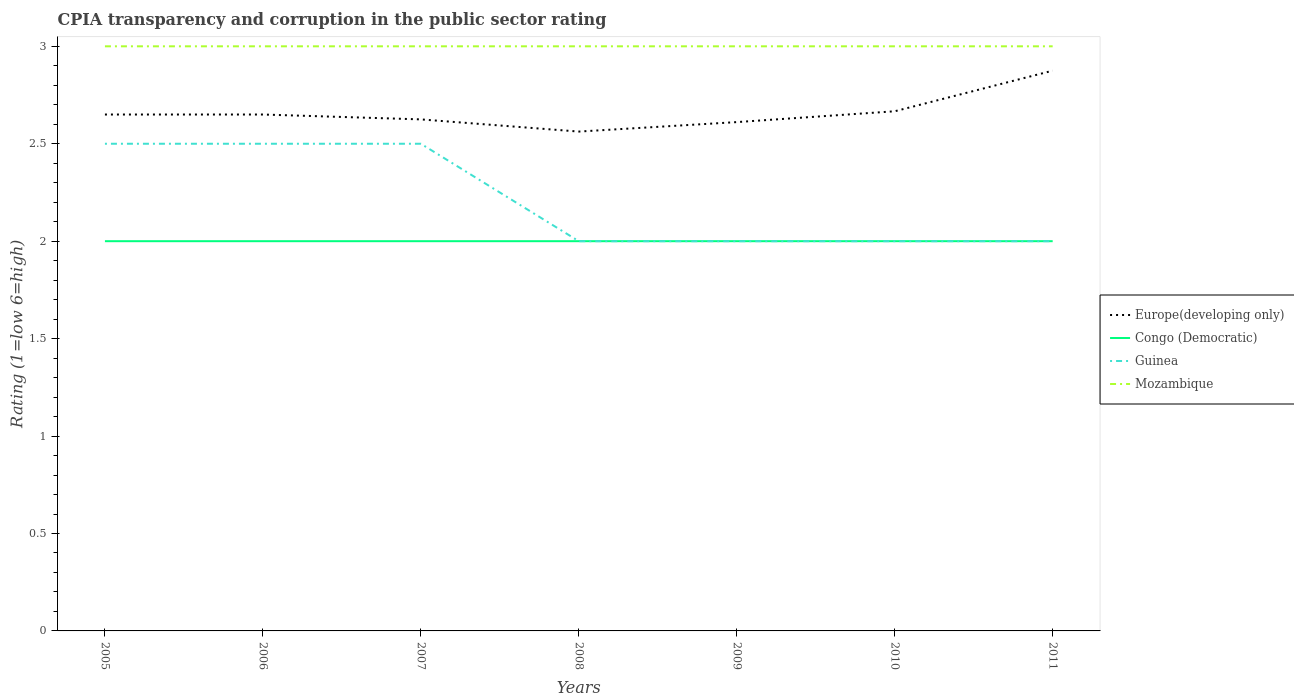Is the number of lines equal to the number of legend labels?
Give a very brief answer. Yes. Across all years, what is the maximum CPIA rating in Europe(developing only)?
Offer a terse response. 2.56. Is the CPIA rating in Europe(developing only) strictly greater than the CPIA rating in Guinea over the years?
Offer a very short reply. No. How many years are there in the graph?
Ensure brevity in your answer.  7. Are the values on the major ticks of Y-axis written in scientific E-notation?
Give a very brief answer. No. How many legend labels are there?
Your answer should be compact. 4. How are the legend labels stacked?
Make the answer very short. Vertical. What is the title of the graph?
Make the answer very short. CPIA transparency and corruption in the public sector rating. What is the label or title of the X-axis?
Provide a short and direct response. Years. What is the Rating (1=low 6=high) of Europe(developing only) in 2005?
Your answer should be compact. 2.65. What is the Rating (1=low 6=high) of Guinea in 2005?
Make the answer very short. 2.5. What is the Rating (1=low 6=high) of Europe(developing only) in 2006?
Provide a succinct answer. 2.65. What is the Rating (1=low 6=high) in Guinea in 2006?
Your answer should be compact. 2.5. What is the Rating (1=low 6=high) in Europe(developing only) in 2007?
Ensure brevity in your answer.  2.62. What is the Rating (1=low 6=high) in Congo (Democratic) in 2007?
Make the answer very short. 2. What is the Rating (1=low 6=high) in Guinea in 2007?
Keep it short and to the point. 2.5. What is the Rating (1=low 6=high) of Europe(developing only) in 2008?
Provide a succinct answer. 2.56. What is the Rating (1=low 6=high) of Congo (Democratic) in 2008?
Provide a short and direct response. 2. What is the Rating (1=low 6=high) of Guinea in 2008?
Offer a very short reply. 2. What is the Rating (1=low 6=high) of Mozambique in 2008?
Offer a very short reply. 3. What is the Rating (1=low 6=high) in Europe(developing only) in 2009?
Offer a terse response. 2.61. What is the Rating (1=low 6=high) of Congo (Democratic) in 2009?
Provide a short and direct response. 2. What is the Rating (1=low 6=high) of Mozambique in 2009?
Make the answer very short. 3. What is the Rating (1=low 6=high) of Europe(developing only) in 2010?
Your answer should be very brief. 2.67. What is the Rating (1=low 6=high) of Congo (Democratic) in 2010?
Make the answer very short. 2. What is the Rating (1=low 6=high) in Guinea in 2010?
Your response must be concise. 2. What is the Rating (1=low 6=high) in Mozambique in 2010?
Give a very brief answer. 3. What is the Rating (1=low 6=high) of Europe(developing only) in 2011?
Give a very brief answer. 2.88. What is the Rating (1=low 6=high) of Mozambique in 2011?
Offer a terse response. 3. Across all years, what is the maximum Rating (1=low 6=high) in Europe(developing only)?
Give a very brief answer. 2.88. Across all years, what is the maximum Rating (1=low 6=high) in Congo (Democratic)?
Make the answer very short. 2. Across all years, what is the maximum Rating (1=low 6=high) of Mozambique?
Keep it short and to the point. 3. Across all years, what is the minimum Rating (1=low 6=high) of Europe(developing only)?
Provide a succinct answer. 2.56. Across all years, what is the minimum Rating (1=low 6=high) of Guinea?
Ensure brevity in your answer.  2. What is the total Rating (1=low 6=high) in Europe(developing only) in the graph?
Offer a very short reply. 18.64. What is the total Rating (1=low 6=high) of Congo (Democratic) in the graph?
Offer a terse response. 14. What is the total Rating (1=low 6=high) in Mozambique in the graph?
Make the answer very short. 21. What is the difference between the Rating (1=low 6=high) of Mozambique in 2005 and that in 2006?
Provide a succinct answer. 0. What is the difference between the Rating (1=low 6=high) of Europe(developing only) in 2005 and that in 2007?
Keep it short and to the point. 0.03. What is the difference between the Rating (1=low 6=high) of Congo (Democratic) in 2005 and that in 2007?
Make the answer very short. 0. What is the difference between the Rating (1=low 6=high) of Mozambique in 2005 and that in 2007?
Provide a succinct answer. 0. What is the difference between the Rating (1=low 6=high) of Europe(developing only) in 2005 and that in 2008?
Ensure brevity in your answer.  0.09. What is the difference between the Rating (1=low 6=high) in Congo (Democratic) in 2005 and that in 2008?
Keep it short and to the point. 0. What is the difference between the Rating (1=low 6=high) in Guinea in 2005 and that in 2008?
Give a very brief answer. 0.5. What is the difference between the Rating (1=low 6=high) in Mozambique in 2005 and that in 2008?
Provide a short and direct response. 0. What is the difference between the Rating (1=low 6=high) in Europe(developing only) in 2005 and that in 2009?
Offer a terse response. 0.04. What is the difference between the Rating (1=low 6=high) of Guinea in 2005 and that in 2009?
Provide a short and direct response. 0.5. What is the difference between the Rating (1=low 6=high) in Europe(developing only) in 2005 and that in 2010?
Provide a short and direct response. -0.02. What is the difference between the Rating (1=low 6=high) in Congo (Democratic) in 2005 and that in 2010?
Offer a terse response. 0. What is the difference between the Rating (1=low 6=high) of Europe(developing only) in 2005 and that in 2011?
Provide a succinct answer. -0.23. What is the difference between the Rating (1=low 6=high) of Congo (Democratic) in 2005 and that in 2011?
Offer a terse response. 0. What is the difference between the Rating (1=low 6=high) in Guinea in 2005 and that in 2011?
Your answer should be compact. 0.5. What is the difference between the Rating (1=low 6=high) in Mozambique in 2005 and that in 2011?
Offer a very short reply. 0. What is the difference between the Rating (1=low 6=high) of Europe(developing only) in 2006 and that in 2007?
Your response must be concise. 0.03. What is the difference between the Rating (1=low 6=high) of Congo (Democratic) in 2006 and that in 2007?
Keep it short and to the point. 0. What is the difference between the Rating (1=low 6=high) of Guinea in 2006 and that in 2007?
Provide a short and direct response. 0. What is the difference between the Rating (1=low 6=high) of Mozambique in 2006 and that in 2007?
Offer a very short reply. 0. What is the difference between the Rating (1=low 6=high) of Europe(developing only) in 2006 and that in 2008?
Offer a very short reply. 0.09. What is the difference between the Rating (1=low 6=high) of Congo (Democratic) in 2006 and that in 2008?
Ensure brevity in your answer.  0. What is the difference between the Rating (1=low 6=high) of Guinea in 2006 and that in 2008?
Offer a very short reply. 0.5. What is the difference between the Rating (1=low 6=high) in Mozambique in 2006 and that in 2008?
Keep it short and to the point. 0. What is the difference between the Rating (1=low 6=high) of Europe(developing only) in 2006 and that in 2009?
Provide a succinct answer. 0.04. What is the difference between the Rating (1=low 6=high) of Congo (Democratic) in 2006 and that in 2009?
Make the answer very short. 0. What is the difference between the Rating (1=low 6=high) of Guinea in 2006 and that in 2009?
Your response must be concise. 0.5. What is the difference between the Rating (1=low 6=high) in Europe(developing only) in 2006 and that in 2010?
Offer a very short reply. -0.02. What is the difference between the Rating (1=low 6=high) in Guinea in 2006 and that in 2010?
Give a very brief answer. 0.5. What is the difference between the Rating (1=low 6=high) of Mozambique in 2006 and that in 2010?
Offer a terse response. 0. What is the difference between the Rating (1=low 6=high) of Europe(developing only) in 2006 and that in 2011?
Your answer should be very brief. -0.23. What is the difference between the Rating (1=low 6=high) of Guinea in 2006 and that in 2011?
Your response must be concise. 0.5. What is the difference between the Rating (1=low 6=high) in Europe(developing only) in 2007 and that in 2008?
Provide a succinct answer. 0.06. What is the difference between the Rating (1=low 6=high) of Europe(developing only) in 2007 and that in 2009?
Offer a terse response. 0.01. What is the difference between the Rating (1=low 6=high) of Guinea in 2007 and that in 2009?
Your answer should be very brief. 0.5. What is the difference between the Rating (1=low 6=high) in Europe(developing only) in 2007 and that in 2010?
Your answer should be very brief. -0.04. What is the difference between the Rating (1=low 6=high) of Congo (Democratic) in 2007 and that in 2010?
Give a very brief answer. 0. What is the difference between the Rating (1=low 6=high) in Congo (Democratic) in 2007 and that in 2011?
Keep it short and to the point. 0. What is the difference between the Rating (1=low 6=high) of Europe(developing only) in 2008 and that in 2009?
Provide a succinct answer. -0.05. What is the difference between the Rating (1=low 6=high) in Congo (Democratic) in 2008 and that in 2009?
Give a very brief answer. 0. What is the difference between the Rating (1=low 6=high) of Guinea in 2008 and that in 2009?
Keep it short and to the point. 0. What is the difference between the Rating (1=low 6=high) of Mozambique in 2008 and that in 2009?
Your response must be concise. 0. What is the difference between the Rating (1=low 6=high) in Europe(developing only) in 2008 and that in 2010?
Make the answer very short. -0.1. What is the difference between the Rating (1=low 6=high) of Mozambique in 2008 and that in 2010?
Provide a succinct answer. 0. What is the difference between the Rating (1=low 6=high) in Europe(developing only) in 2008 and that in 2011?
Your answer should be compact. -0.31. What is the difference between the Rating (1=low 6=high) in Congo (Democratic) in 2008 and that in 2011?
Keep it short and to the point. 0. What is the difference between the Rating (1=low 6=high) in Europe(developing only) in 2009 and that in 2010?
Ensure brevity in your answer.  -0.06. What is the difference between the Rating (1=low 6=high) of Congo (Democratic) in 2009 and that in 2010?
Your response must be concise. 0. What is the difference between the Rating (1=low 6=high) in Europe(developing only) in 2009 and that in 2011?
Your answer should be very brief. -0.26. What is the difference between the Rating (1=low 6=high) in Guinea in 2009 and that in 2011?
Keep it short and to the point. 0. What is the difference between the Rating (1=low 6=high) in Europe(developing only) in 2010 and that in 2011?
Make the answer very short. -0.21. What is the difference between the Rating (1=low 6=high) in Congo (Democratic) in 2010 and that in 2011?
Make the answer very short. 0. What is the difference between the Rating (1=low 6=high) of Guinea in 2010 and that in 2011?
Your response must be concise. 0. What is the difference between the Rating (1=low 6=high) in Mozambique in 2010 and that in 2011?
Offer a very short reply. 0. What is the difference between the Rating (1=low 6=high) of Europe(developing only) in 2005 and the Rating (1=low 6=high) of Congo (Democratic) in 2006?
Provide a short and direct response. 0.65. What is the difference between the Rating (1=low 6=high) in Europe(developing only) in 2005 and the Rating (1=low 6=high) in Guinea in 2006?
Offer a terse response. 0.15. What is the difference between the Rating (1=low 6=high) in Europe(developing only) in 2005 and the Rating (1=low 6=high) in Mozambique in 2006?
Offer a very short reply. -0.35. What is the difference between the Rating (1=low 6=high) in Congo (Democratic) in 2005 and the Rating (1=low 6=high) in Guinea in 2006?
Ensure brevity in your answer.  -0.5. What is the difference between the Rating (1=low 6=high) of Congo (Democratic) in 2005 and the Rating (1=low 6=high) of Mozambique in 2006?
Make the answer very short. -1. What is the difference between the Rating (1=low 6=high) in Guinea in 2005 and the Rating (1=low 6=high) in Mozambique in 2006?
Your response must be concise. -0.5. What is the difference between the Rating (1=low 6=high) in Europe(developing only) in 2005 and the Rating (1=low 6=high) in Congo (Democratic) in 2007?
Give a very brief answer. 0.65. What is the difference between the Rating (1=low 6=high) of Europe(developing only) in 2005 and the Rating (1=low 6=high) of Mozambique in 2007?
Make the answer very short. -0.35. What is the difference between the Rating (1=low 6=high) in Congo (Democratic) in 2005 and the Rating (1=low 6=high) in Mozambique in 2007?
Offer a terse response. -1. What is the difference between the Rating (1=low 6=high) of Europe(developing only) in 2005 and the Rating (1=low 6=high) of Congo (Democratic) in 2008?
Offer a terse response. 0.65. What is the difference between the Rating (1=low 6=high) in Europe(developing only) in 2005 and the Rating (1=low 6=high) in Guinea in 2008?
Give a very brief answer. 0.65. What is the difference between the Rating (1=low 6=high) of Europe(developing only) in 2005 and the Rating (1=low 6=high) of Mozambique in 2008?
Make the answer very short. -0.35. What is the difference between the Rating (1=low 6=high) of Congo (Democratic) in 2005 and the Rating (1=low 6=high) of Guinea in 2008?
Offer a very short reply. 0. What is the difference between the Rating (1=low 6=high) of Guinea in 2005 and the Rating (1=low 6=high) of Mozambique in 2008?
Your response must be concise. -0.5. What is the difference between the Rating (1=low 6=high) of Europe(developing only) in 2005 and the Rating (1=low 6=high) of Congo (Democratic) in 2009?
Provide a short and direct response. 0.65. What is the difference between the Rating (1=low 6=high) in Europe(developing only) in 2005 and the Rating (1=low 6=high) in Guinea in 2009?
Give a very brief answer. 0.65. What is the difference between the Rating (1=low 6=high) of Europe(developing only) in 2005 and the Rating (1=low 6=high) of Mozambique in 2009?
Your answer should be compact. -0.35. What is the difference between the Rating (1=low 6=high) of Congo (Democratic) in 2005 and the Rating (1=low 6=high) of Guinea in 2009?
Your response must be concise. 0. What is the difference between the Rating (1=low 6=high) of Guinea in 2005 and the Rating (1=low 6=high) of Mozambique in 2009?
Keep it short and to the point. -0.5. What is the difference between the Rating (1=low 6=high) in Europe(developing only) in 2005 and the Rating (1=low 6=high) in Congo (Democratic) in 2010?
Keep it short and to the point. 0.65. What is the difference between the Rating (1=low 6=high) in Europe(developing only) in 2005 and the Rating (1=low 6=high) in Guinea in 2010?
Provide a succinct answer. 0.65. What is the difference between the Rating (1=low 6=high) of Europe(developing only) in 2005 and the Rating (1=low 6=high) of Mozambique in 2010?
Your response must be concise. -0.35. What is the difference between the Rating (1=low 6=high) in Congo (Democratic) in 2005 and the Rating (1=low 6=high) in Mozambique in 2010?
Offer a very short reply. -1. What is the difference between the Rating (1=low 6=high) in Europe(developing only) in 2005 and the Rating (1=low 6=high) in Congo (Democratic) in 2011?
Offer a terse response. 0.65. What is the difference between the Rating (1=low 6=high) of Europe(developing only) in 2005 and the Rating (1=low 6=high) of Guinea in 2011?
Offer a terse response. 0.65. What is the difference between the Rating (1=low 6=high) in Europe(developing only) in 2005 and the Rating (1=low 6=high) in Mozambique in 2011?
Ensure brevity in your answer.  -0.35. What is the difference between the Rating (1=low 6=high) in Europe(developing only) in 2006 and the Rating (1=low 6=high) in Congo (Democratic) in 2007?
Keep it short and to the point. 0.65. What is the difference between the Rating (1=low 6=high) of Europe(developing only) in 2006 and the Rating (1=low 6=high) of Guinea in 2007?
Ensure brevity in your answer.  0.15. What is the difference between the Rating (1=low 6=high) in Europe(developing only) in 2006 and the Rating (1=low 6=high) in Mozambique in 2007?
Offer a very short reply. -0.35. What is the difference between the Rating (1=low 6=high) in Congo (Democratic) in 2006 and the Rating (1=low 6=high) in Guinea in 2007?
Keep it short and to the point. -0.5. What is the difference between the Rating (1=low 6=high) in Congo (Democratic) in 2006 and the Rating (1=low 6=high) in Mozambique in 2007?
Give a very brief answer. -1. What is the difference between the Rating (1=low 6=high) in Europe(developing only) in 2006 and the Rating (1=low 6=high) in Congo (Democratic) in 2008?
Ensure brevity in your answer.  0.65. What is the difference between the Rating (1=low 6=high) in Europe(developing only) in 2006 and the Rating (1=low 6=high) in Guinea in 2008?
Provide a short and direct response. 0.65. What is the difference between the Rating (1=low 6=high) in Europe(developing only) in 2006 and the Rating (1=low 6=high) in Mozambique in 2008?
Your answer should be compact. -0.35. What is the difference between the Rating (1=low 6=high) in Congo (Democratic) in 2006 and the Rating (1=low 6=high) in Mozambique in 2008?
Ensure brevity in your answer.  -1. What is the difference between the Rating (1=low 6=high) in Guinea in 2006 and the Rating (1=low 6=high) in Mozambique in 2008?
Offer a very short reply. -0.5. What is the difference between the Rating (1=low 6=high) of Europe(developing only) in 2006 and the Rating (1=low 6=high) of Congo (Democratic) in 2009?
Make the answer very short. 0.65. What is the difference between the Rating (1=low 6=high) in Europe(developing only) in 2006 and the Rating (1=low 6=high) in Guinea in 2009?
Provide a succinct answer. 0.65. What is the difference between the Rating (1=low 6=high) of Europe(developing only) in 2006 and the Rating (1=low 6=high) of Mozambique in 2009?
Offer a terse response. -0.35. What is the difference between the Rating (1=low 6=high) of Europe(developing only) in 2006 and the Rating (1=low 6=high) of Congo (Democratic) in 2010?
Provide a short and direct response. 0.65. What is the difference between the Rating (1=low 6=high) in Europe(developing only) in 2006 and the Rating (1=low 6=high) in Guinea in 2010?
Provide a short and direct response. 0.65. What is the difference between the Rating (1=low 6=high) of Europe(developing only) in 2006 and the Rating (1=low 6=high) of Mozambique in 2010?
Your response must be concise. -0.35. What is the difference between the Rating (1=low 6=high) in Congo (Democratic) in 2006 and the Rating (1=low 6=high) in Guinea in 2010?
Offer a very short reply. 0. What is the difference between the Rating (1=low 6=high) in Guinea in 2006 and the Rating (1=low 6=high) in Mozambique in 2010?
Your response must be concise. -0.5. What is the difference between the Rating (1=low 6=high) of Europe(developing only) in 2006 and the Rating (1=low 6=high) of Congo (Democratic) in 2011?
Offer a terse response. 0.65. What is the difference between the Rating (1=low 6=high) of Europe(developing only) in 2006 and the Rating (1=low 6=high) of Guinea in 2011?
Your answer should be compact. 0.65. What is the difference between the Rating (1=low 6=high) in Europe(developing only) in 2006 and the Rating (1=low 6=high) in Mozambique in 2011?
Offer a very short reply. -0.35. What is the difference between the Rating (1=low 6=high) of Congo (Democratic) in 2006 and the Rating (1=low 6=high) of Guinea in 2011?
Offer a very short reply. 0. What is the difference between the Rating (1=low 6=high) in Guinea in 2006 and the Rating (1=low 6=high) in Mozambique in 2011?
Provide a short and direct response. -0.5. What is the difference between the Rating (1=low 6=high) of Europe(developing only) in 2007 and the Rating (1=low 6=high) of Guinea in 2008?
Keep it short and to the point. 0.62. What is the difference between the Rating (1=low 6=high) of Europe(developing only) in 2007 and the Rating (1=low 6=high) of Mozambique in 2008?
Make the answer very short. -0.38. What is the difference between the Rating (1=low 6=high) of Congo (Democratic) in 2007 and the Rating (1=low 6=high) of Mozambique in 2008?
Ensure brevity in your answer.  -1. What is the difference between the Rating (1=low 6=high) in Europe(developing only) in 2007 and the Rating (1=low 6=high) in Congo (Democratic) in 2009?
Your answer should be compact. 0.62. What is the difference between the Rating (1=low 6=high) of Europe(developing only) in 2007 and the Rating (1=low 6=high) of Guinea in 2009?
Provide a short and direct response. 0.62. What is the difference between the Rating (1=low 6=high) of Europe(developing only) in 2007 and the Rating (1=low 6=high) of Mozambique in 2009?
Provide a short and direct response. -0.38. What is the difference between the Rating (1=low 6=high) of Congo (Democratic) in 2007 and the Rating (1=low 6=high) of Mozambique in 2009?
Keep it short and to the point. -1. What is the difference between the Rating (1=low 6=high) of Europe(developing only) in 2007 and the Rating (1=low 6=high) of Guinea in 2010?
Offer a very short reply. 0.62. What is the difference between the Rating (1=low 6=high) of Europe(developing only) in 2007 and the Rating (1=low 6=high) of Mozambique in 2010?
Provide a short and direct response. -0.38. What is the difference between the Rating (1=low 6=high) of Congo (Democratic) in 2007 and the Rating (1=low 6=high) of Mozambique in 2010?
Ensure brevity in your answer.  -1. What is the difference between the Rating (1=low 6=high) of Guinea in 2007 and the Rating (1=low 6=high) of Mozambique in 2010?
Keep it short and to the point. -0.5. What is the difference between the Rating (1=low 6=high) in Europe(developing only) in 2007 and the Rating (1=low 6=high) in Guinea in 2011?
Ensure brevity in your answer.  0.62. What is the difference between the Rating (1=low 6=high) of Europe(developing only) in 2007 and the Rating (1=low 6=high) of Mozambique in 2011?
Your answer should be very brief. -0.38. What is the difference between the Rating (1=low 6=high) in Congo (Democratic) in 2007 and the Rating (1=low 6=high) in Guinea in 2011?
Offer a terse response. 0. What is the difference between the Rating (1=low 6=high) in Europe(developing only) in 2008 and the Rating (1=low 6=high) in Congo (Democratic) in 2009?
Keep it short and to the point. 0.56. What is the difference between the Rating (1=low 6=high) in Europe(developing only) in 2008 and the Rating (1=low 6=high) in Guinea in 2009?
Offer a terse response. 0.56. What is the difference between the Rating (1=low 6=high) of Europe(developing only) in 2008 and the Rating (1=low 6=high) of Mozambique in 2009?
Your response must be concise. -0.44. What is the difference between the Rating (1=low 6=high) of Congo (Democratic) in 2008 and the Rating (1=low 6=high) of Guinea in 2009?
Offer a very short reply. 0. What is the difference between the Rating (1=low 6=high) in Congo (Democratic) in 2008 and the Rating (1=low 6=high) in Mozambique in 2009?
Provide a short and direct response. -1. What is the difference between the Rating (1=low 6=high) in Europe(developing only) in 2008 and the Rating (1=low 6=high) in Congo (Democratic) in 2010?
Offer a very short reply. 0.56. What is the difference between the Rating (1=low 6=high) in Europe(developing only) in 2008 and the Rating (1=low 6=high) in Guinea in 2010?
Your response must be concise. 0.56. What is the difference between the Rating (1=low 6=high) in Europe(developing only) in 2008 and the Rating (1=low 6=high) in Mozambique in 2010?
Keep it short and to the point. -0.44. What is the difference between the Rating (1=low 6=high) of Congo (Democratic) in 2008 and the Rating (1=low 6=high) of Guinea in 2010?
Give a very brief answer. 0. What is the difference between the Rating (1=low 6=high) of Guinea in 2008 and the Rating (1=low 6=high) of Mozambique in 2010?
Ensure brevity in your answer.  -1. What is the difference between the Rating (1=low 6=high) in Europe(developing only) in 2008 and the Rating (1=low 6=high) in Congo (Democratic) in 2011?
Your answer should be very brief. 0.56. What is the difference between the Rating (1=low 6=high) of Europe(developing only) in 2008 and the Rating (1=low 6=high) of Guinea in 2011?
Offer a terse response. 0.56. What is the difference between the Rating (1=low 6=high) in Europe(developing only) in 2008 and the Rating (1=low 6=high) in Mozambique in 2011?
Keep it short and to the point. -0.44. What is the difference between the Rating (1=low 6=high) of Congo (Democratic) in 2008 and the Rating (1=low 6=high) of Guinea in 2011?
Make the answer very short. 0. What is the difference between the Rating (1=low 6=high) in Congo (Democratic) in 2008 and the Rating (1=low 6=high) in Mozambique in 2011?
Ensure brevity in your answer.  -1. What is the difference between the Rating (1=low 6=high) in Europe(developing only) in 2009 and the Rating (1=low 6=high) in Congo (Democratic) in 2010?
Your response must be concise. 0.61. What is the difference between the Rating (1=low 6=high) of Europe(developing only) in 2009 and the Rating (1=low 6=high) of Guinea in 2010?
Provide a succinct answer. 0.61. What is the difference between the Rating (1=low 6=high) in Europe(developing only) in 2009 and the Rating (1=low 6=high) in Mozambique in 2010?
Offer a very short reply. -0.39. What is the difference between the Rating (1=low 6=high) in Europe(developing only) in 2009 and the Rating (1=low 6=high) in Congo (Democratic) in 2011?
Your response must be concise. 0.61. What is the difference between the Rating (1=low 6=high) in Europe(developing only) in 2009 and the Rating (1=low 6=high) in Guinea in 2011?
Your answer should be very brief. 0.61. What is the difference between the Rating (1=low 6=high) of Europe(developing only) in 2009 and the Rating (1=low 6=high) of Mozambique in 2011?
Ensure brevity in your answer.  -0.39. What is the difference between the Rating (1=low 6=high) in Congo (Democratic) in 2009 and the Rating (1=low 6=high) in Guinea in 2011?
Make the answer very short. 0. What is the difference between the Rating (1=low 6=high) of Congo (Democratic) in 2009 and the Rating (1=low 6=high) of Mozambique in 2011?
Offer a very short reply. -1. What is the difference between the Rating (1=low 6=high) in Guinea in 2009 and the Rating (1=low 6=high) in Mozambique in 2011?
Give a very brief answer. -1. What is the difference between the Rating (1=low 6=high) in Europe(developing only) in 2010 and the Rating (1=low 6=high) in Guinea in 2011?
Provide a succinct answer. 0.67. What is the difference between the Rating (1=low 6=high) of Guinea in 2010 and the Rating (1=low 6=high) of Mozambique in 2011?
Keep it short and to the point. -1. What is the average Rating (1=low 6=high) of Europe(developing only) per year?
Your response must be concise. 2.66. What is the average Rating (1=low 6=high) in Guinea per year?
Ensure brevity in your answer.  2.21. In the year 2005, what is the difference between the Rating (1=low 6=high) of Europe(developing only) and Rating (1=low 6=high) of Congo (Democratic)?
Offer a very short reply. 0.65. In the year 2005, what is the difference between the Rating (1=low 6=high) of Europe(developing only) and Rating (1=low 6=high) of Guinea?
Provide a short and direct response. 0.15. In the year 2005, what is the difference between the Rating (1=low 6=high) of Europe(developing only) and Rating (1=low 6=high) of Mozambique?
Offer a terse response. -0.35. In the year 2005, what is the difference between the Rating (1=low 6=high) in Congo (Democratic) and Rating (1=low 6=high) in Guinea?
Give a very brief answer. -0.5. In the year 2005, what is the difference between the Rating (1=low 6=high) of Congo (Democratic) and Rating (1=low 6=high) of Mozambique?
Provide a succinct answer. -1. In the year 2006, what is the difference between the Rating (1=low 6=high) in Europe(developing only) and Rating (1=low 6=high) in Congo (Democratic)?
Keep it short and to the point. 0.65. In the year 2006, what is the difference between the Rating (1=low 6=high) of Europe(developing only) and Rating (1=low 6=high) of Guinea?
Ensure brevity in your answer.  0.15. In the year 2006, what is the difference between the Rating (1=low 6=high) in Europe(developing only) and Rating (1=low 6=high) in Mozambique?
Keep it short and to the point. -0.35. In the year 2006, what is the difference between the Rating (1=low 6=high) of Congo (Democratic) and Rating (1=low 6=high) of Guinea?
Provide a short and direct response. -0.5. In the year 2007, what is the difference between the Rating (1=low 6=high) of Europe(developing only) and Rating (1=low 6=high) of Congo (Democratic)?
Your response must be concise. 0.62. In the year 2007, what is the difference between the Rating (1=low 6=high) of Europe(developing only) and Rating (1=low 6=high) of Guinea?
Give a very brief answer. 0.12. In the year 2007, what is the difference between the Rating (1=low 6=high) of Europe(developing only) and Rating (1=low 6=high) of Mozambique?
Keep it short and to the point. -0.38. In the year 2007, what is the difference between the Rating (1=low 6=high) of Congo (Democratic) and Rating (1=low 6=high) of Mozambique?
Your answer should be very brief. -1. In the year 2007, what is the difference between the Rating (1=low 6=high) of Guinea and Rating (1=low 6=high) of Mozambique?
Provide a short and direct response. -0.5. In the year 2008, what is the difference between the Rating (1=low 6=high) of Europe(developing only) and Rating (1=low 6=high) of Congo (Democratic)?
Keep it short and to the point. 0.56. In the year 2008, what is the difference between the Rating (1=low 6=high) of Europe(developing only) and Rating (1=low 6=high) of Guinea?
Your answer should be compact. 0.56. In the year 2008, what is the difference between the Rating (1=low 6=high) in Europe(developing only) and Rating (1=low 6=high) in Mozambique?
Provide a short and direct response. -0.44. In the year 2008, what is the difference between the Rating (1=low 6=high) of Congo (Democratic) and Rating (1=low 6=high) of Guinea?
Your answer should be very brief. 0. In the year 2008, what is the difference between the Rating (1=low 6=high) in Guinea and Rating (1=low 6=high) in Mozambique?
Ensure brevity in your answer.  -1. In the year 2009, what is the difference between the Rating (1=low 6=high) of Europe(developing only) and Rating (1=low 6=high) of Congo (Democratic)?
Make the answer very short. 0.61. In the year 2009, what is the difference between the Rating (1=low 6=high) of Europe(developing only) and Rating (1=low 6=high) of Guinea?
Make the answer very short. 0.61. In the year 2009, what is the difference between the Rating (1=low 6=high) of Europe(developing only) and Rating (1=low 6=high) of Mozambique?
Ensure brevity in your answer.  -0.39. In the year 2009, what is the difference between the Rating (1=low 6=high) of Congo (Democratic) and Rating (1=low 6=high) of Mozambique?
Your response must be concise. -1. In the year 2010, what is the difference between the Rating (1=low 6=high) of Europe(developing only) and Rating (1=low 6=high) of Guinea?
Offer a very short reply. 0.67. In the year 2010, what is the difference between the Rating (1=low 6=high) of Europe(developing only) and Rating (1=low 6=high) of Mozambique?
Make the answer very short. -0.33. In the year 2010, what is the difference between the Rating (1=low 6=high) in Congo (Democratic) and Rating (1=low 6=high) in Mozambique?
Your answer should be compact. -1. In the year 2011, what is the difference between the Rating (1=low 6=high) in Europe(developing only) and Rating (1=low 6=high) in Congo (Democratic)?
Keep it short and to the point. 0.88. In the year 2011, what is the difference between the Rating (1=low 6=high) of Europe(developing only) and Rating (1=low 6=high) of Guinea?
Provide a succinct answer. 0.88. In the year 2011, what is the difference between the Rating (1=low 6=high) in Europe(developing only) and Rating (1=low 6=high) in Mozambique?
Offer a terse response. -0.12. In the year 2011, what is the difference between the Rating (1=low 6=high) in Congo (Democratic) and Rating (1=low 6=high) in Guinea?
Keep it short and to the point. 0. In the year 2011, what is the difference between the Rating (1=low 6=high) of Guinea and Rating (1=low 6=high) of Mozambique?
Provide a short and direct response. -1. What is the ratio of the Rating (1=low 6=high) in Europe(developing only) in 2005 to that in 2007?
Offer a very short reply. 1.01. What is the ratio of the Rating (1=low 6=high) in Mozambique in 2005 to that in 2007?
Offer a terse response. 1. What is the ratio of the Rating (1=low 6=high) in Europe(developing only) in 2005 to that in 2008?
Make the answer very short. 1.03. What is the ratio of the Rating (1=low 6=high) of Congo (Democratic) in 2005 to that in 2008?
Ensure brevity in your answer.  1. What is the ratio of the Rating (1=low 6=high) in Guinea in 2005 to that in 2008?
Your answer should be compact. 1.25. What is the ratio of the Rating (1=low 6=high) of Mozambique in 2005 to that in 2008?
Your answer should be very brief. 1. What is the ratio of the Rating (1=low 6=high) in Europe(developing only) in 2005 to that in 2009?
Make the answer very short. 1.01. What is the ratio of the Rating (1=low 6=high) in Guinea in 2005 to that in 2009?
Offer a very short reply. 1.25. What is the ratio of the Rating (1=low 6=high) of Europe(developing only) in 2005 to that in 2010?
Provide a succinct answer. 0.99. What is the ratio of the Rating (1=low 6=high) of Mozambique in 2005 to that in 2010?
Your answer should be compact. 1. What is the ratio of the Rating (1=low 6=high) in Europe(developing only) in 2005 to that in 2011?
Give a very brief answer. 0.92. What is the ratio of the Rating (1=low 6=high) in Congo (Democratic) in 2005 to that in 2011?
Give a very brief answer. 1. What is the ratio of the Rating (1=low 6=high) in Mozambique in 2005 to that in 2011?
Provide a short and direct response. 1. What is the ratio of the Rating (1=low 6=high) of Europe(developing only) in 2006 to that in 2007?
Your answer should be very brief. 1.01. What is the ratio of the Rating (1=low 6=high) of Congo (Democratic) in 2006 to that in 2007?
Keep it short and to the point. 1. What is the ratio of the Rating (1=low 6=high) of Europe(developing only) in 2006 to that in 2008?
Ensure brevity in your answer.  1.03. What is the ratio of the Rating (1=low 6=high) of Congo (Democratic) in 2006 to that in 2008?
Provide a succinct answer. 1. What is the ratio of the Rating (1=low 6=high) of Europe(developing only) in 2006 to that in 2009?
Offer a very short reply. 1.01. What is the ratio of the Rating (1=low 6=high) in Mozambique in 2006 to that in 2009?
Your answer should be very brief. 1. What is the ratio of the Rating (1=low 6=high) of Congo (Democratic) in 2006 to that in 2010?
Ensure brevity in your answer.  1. What is the ratio of the Rating (1=low 6=high) in Guinea in 2006 to that in 2010?
Ensure brevity in your answer.  1.25. What is the ratio of the Rating (1=low 6=high) of Europe(developing only) in 2006 to that in 2011?
Provide a succinct answer. 0.92. What is the ratio of the Rating (1=low 6=high) of Guinea in 2006 to that in 2011?
Ensure brevity in your answer.  1.25. What is the ratio of the Rating (1=low 6=high) in Europe(developing only) in 2007 to that in 2008?
Offer a terse response. 1.02. What is the ratio of the Rating (1=low 6=high) of Congo (Democratic) in 2007 to that in 2008?
Your response must be concise. 1. What is the ratio of the Rating (1=low 6=high) in Europe(developing only) in 2007 to that in 2010?
Keep it short and to the point. 0.98. What is the ratio of the Rating (1=low 6=high) of Mozambique in 2007 to that in 2010?
Your response must be concise. 1. What is the ratio of the Rating (1=low 6=high) of Europe(developing only) in 2008 to that in 2009?
Your response must be concise. 0.98. What is the ratio of the Rating (1=low 6=high) in Europe(developing only) in 2008 to that in 2010?
Your response must be concise. 0.96. What is the ratio of the Rating (1=low 6=high) of Europe(developing only) in 2008 to that in 2011?
Offer a very short reply. 0.89. What is the ratio of the Rating (1=low 6=high) of Congo (Democratic) in 2008 to that in 2011?
Your answer should be compact. 1. What is the ratio of the Rating (1=low 6=high) of Guinea in 2008 to that in 2011?
Provide a succinct answer. 1. What is the ratio of the Rating (1=low 6=high) of Europe(developing only) in 2009 to that in 2010?
Provide a succinct answer. 0.98. What is the ratio of the Rating (1=low 6=high) of Congo (Democratic) in 2009 to that in 2010?
Offer a very short reply. 1. What is the ratio of the Rating (1=low 6=high) in Mozambique in 2009 to that in 2010?
Make the answer very short. 1. What is the ratio of the Rating (1=low 6=high) in Europe(developing only) in 2009 to that in 2011?
Provide a succinct answer. 0.91. What is the ratio of the Rating (1=low 6=high) in Congo (Democratic) in 2009 to that in 2011?
Give a very brief answer. 1. What is the ratio of the Rating (1=low 6=high) of Guinea in 2009 to that in 2011?
Give a very brief answer. 1. What is the ratio of the Rating (1=low 6=high) in Mozambique in 2009 to that in 2011?
Your answer should be compact. 1. What is the ratio of the Rating (1=low 6=high) of Europe(developing only) in 2010 to that in 2011?
Your answer should be very brief. 0.93. What is the ratio of the Rating (1=low 6=high) of Congo (Democratic) in 2010 to that in 2011?
Offer a terse response. 1. What is the difference between the highest and the second highest Rating (1=low 6=high) of Europe(developing only)?
Your answer should be very brief. 0.21. What is the difference between the highest and the second highest Rating (1=low 6=high) of Guinea?
Give a very brief answer. 0. What is the difference between the highest and the second highest Rating (1=low 6=high) in Mozambique?
Give a very brief answer. 0. What is the difference between the highest and the lowest Rating (1=low 6=high) of Europe(developing only)?
Offer a terse response. 0.31. What is the difference between the highest and the lowest Rating (1=low 6=high) of Congo (Democratic)?
Offer a terse response. 0. What is the difference between the highest and the lowest Rating (1=low 6=high) in Mozambique?
Offer a very short reply. 0. 